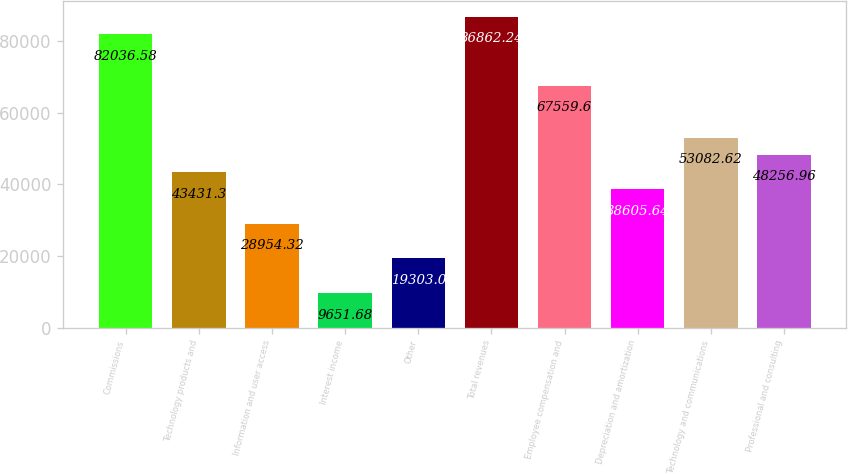Convert chart to OTSL. <chart><loc_0><loc_0><loc_500><loc_500><bar_chart><fcel>Commissions<fcel>Technology products and<fcel>Information and user access<fcel>Interest income<fcel>Other<fcel>Total revenues<fcel>Employee compensation and<fcel>Depreciation and amortization<fcel>Technology and communications<fcel>Professional and consulting<nl><fcel>82036.6<fcel>43431.3<fcel>28954.3<fcel>9651.68<fcel>19303<fcel>86862.2<fcel>67559.6<fcel>38605.6<fcel>53082.6<fcel>48257<nl></chart> 